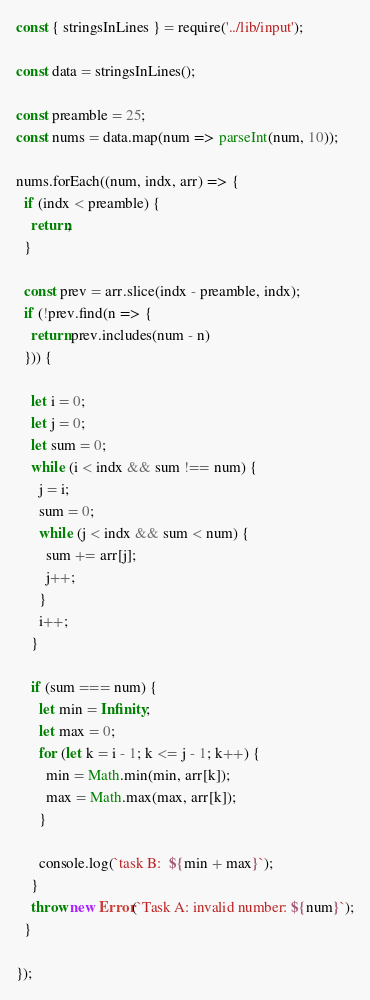<code> <loc_0><loc_0><loc_500><loc_500><_JavaScript_>const { stringsInLines } = require('../lib/input');

const data = stringsInLines();

const preamble = 25;
const nums = data.map(num => parseInt(num, 10));

nums.forEach((num, indx, arr) => {
  if (indx < preamble) {
    return;
  }

  const prev = arr.slice(indx - preamble, indx);
  if (!prev.find(n => {
    return prev.includes(num - n)
  })) {

    let i = 0;
    let j = 0;
    let sum = 0;
    while (i < indx && sum !== num) {
      j = i;
      sum = 0;
      while (j < indx && sum < num) {
        sum += arr[j];
        j++;
      }
      i++;
    }

    if (sum === num) {
      let min = Infinity;
      let max = 0;
      for (let k = i - 1; k <= j - 1; k++) {
        min = Math.min(min, arr[k]);
        max = Math.max(max, arr[k]);
      }

      console.log(`task B:  ${min + max}`);
    }
    throw new Error(`Task A: invalid number: ${num}`);
  }

});
</code> 